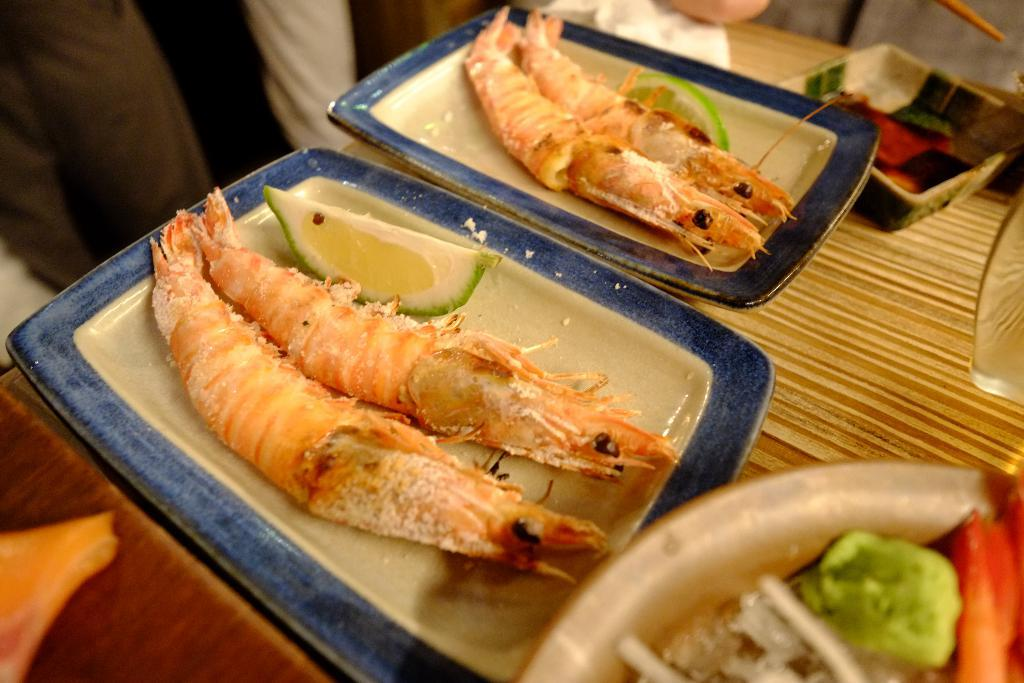What type of food is visible in the image? There are prawns in the image. What accompaniment is present with the prawns? There is a piece of lime in the image. How are the prawns and lime arranged in the image? The prawns and lime are kept in plates. What condiment is available in the image? There is a bowl of soya sauce in the image. Where are the plates and bowl placed in the image? The plates and bowl are kept on a table. What type of wealth is displayed on the table in the image? There is no display of wealth in the image; it features prawns, lime, soya sauce, and plates on a table. Can you provide the receipt for the meal in the image? There is no receipt present in the image, as it is a still photograph of food items. 